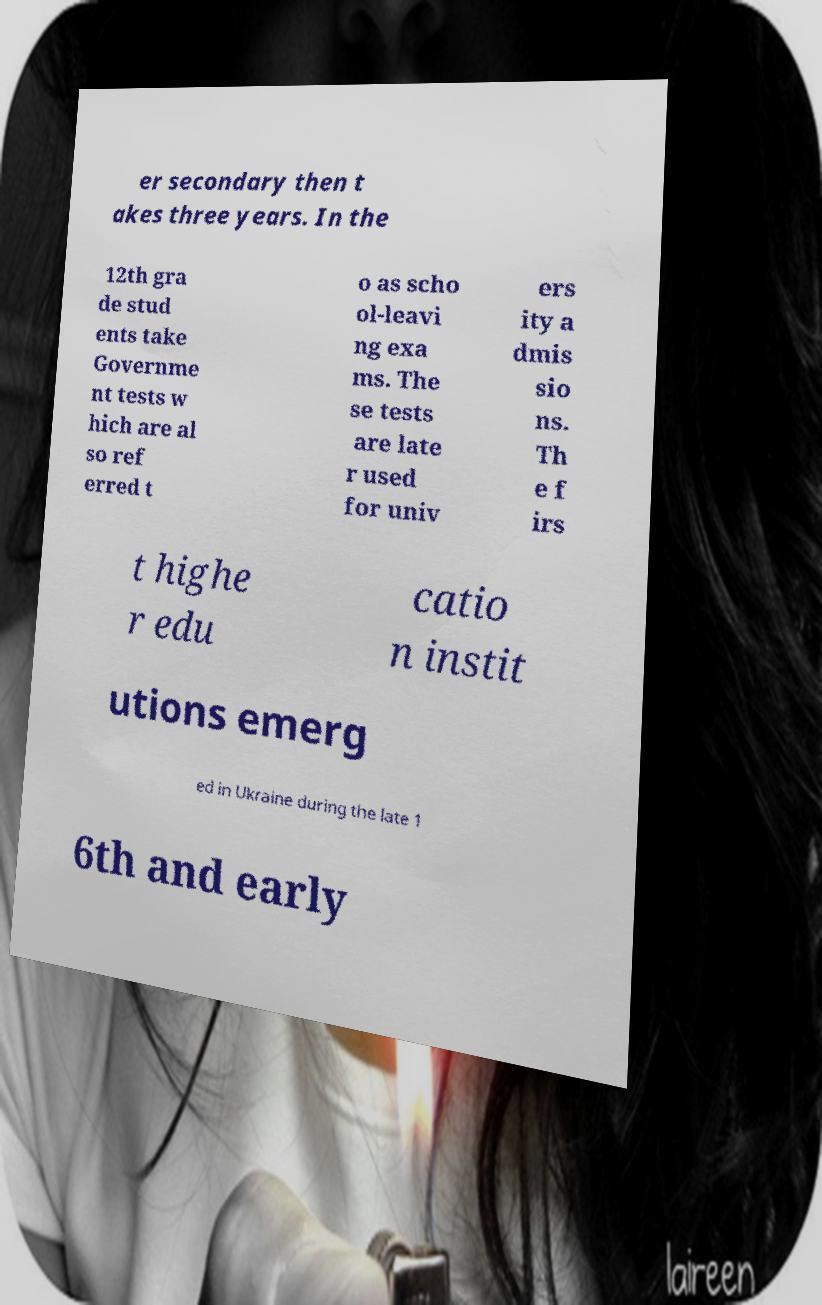There's text embedded in this image that I need extracted. Can you transcribe it verbatim? er secondary then t akes three years. In the 12th gra de stud ents take Governme nt tests w hich are al so ref erred t o as scho ol-leavi ng exa ms. The se tests are late r used for univ ers ity a dmis sio ns. Th e f irs t highe r edu catio n instit utions emerg ed in Ukraine during the late 1 6th and early 